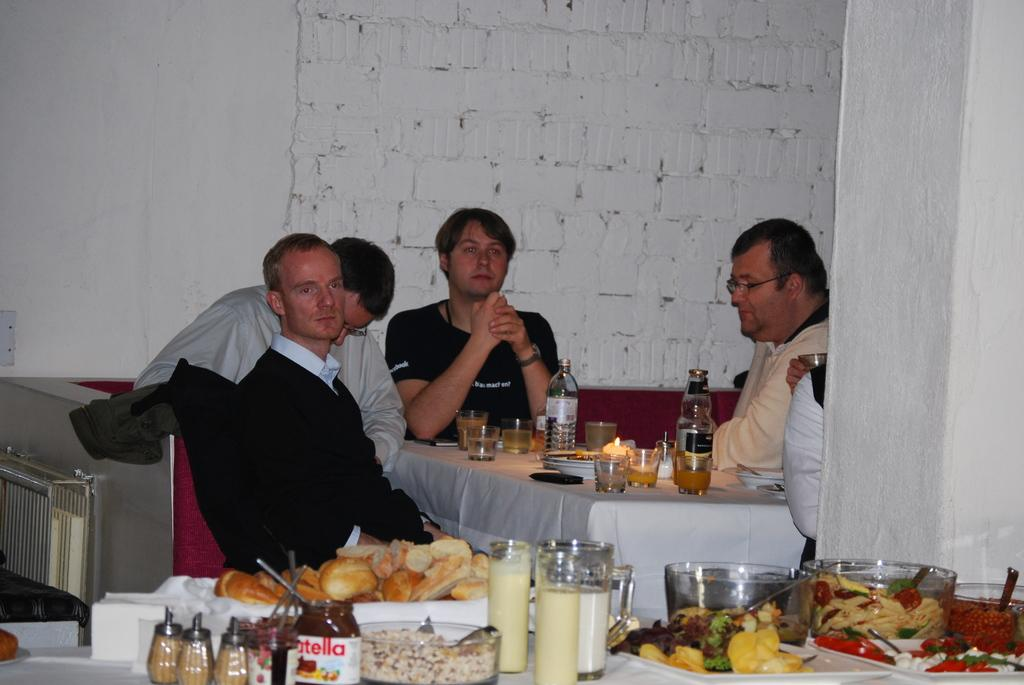<image>
Present a compact description of the photo's key features. People are sitting at a table in a restaurant and a jar of nutella can be seen in the foreground. 